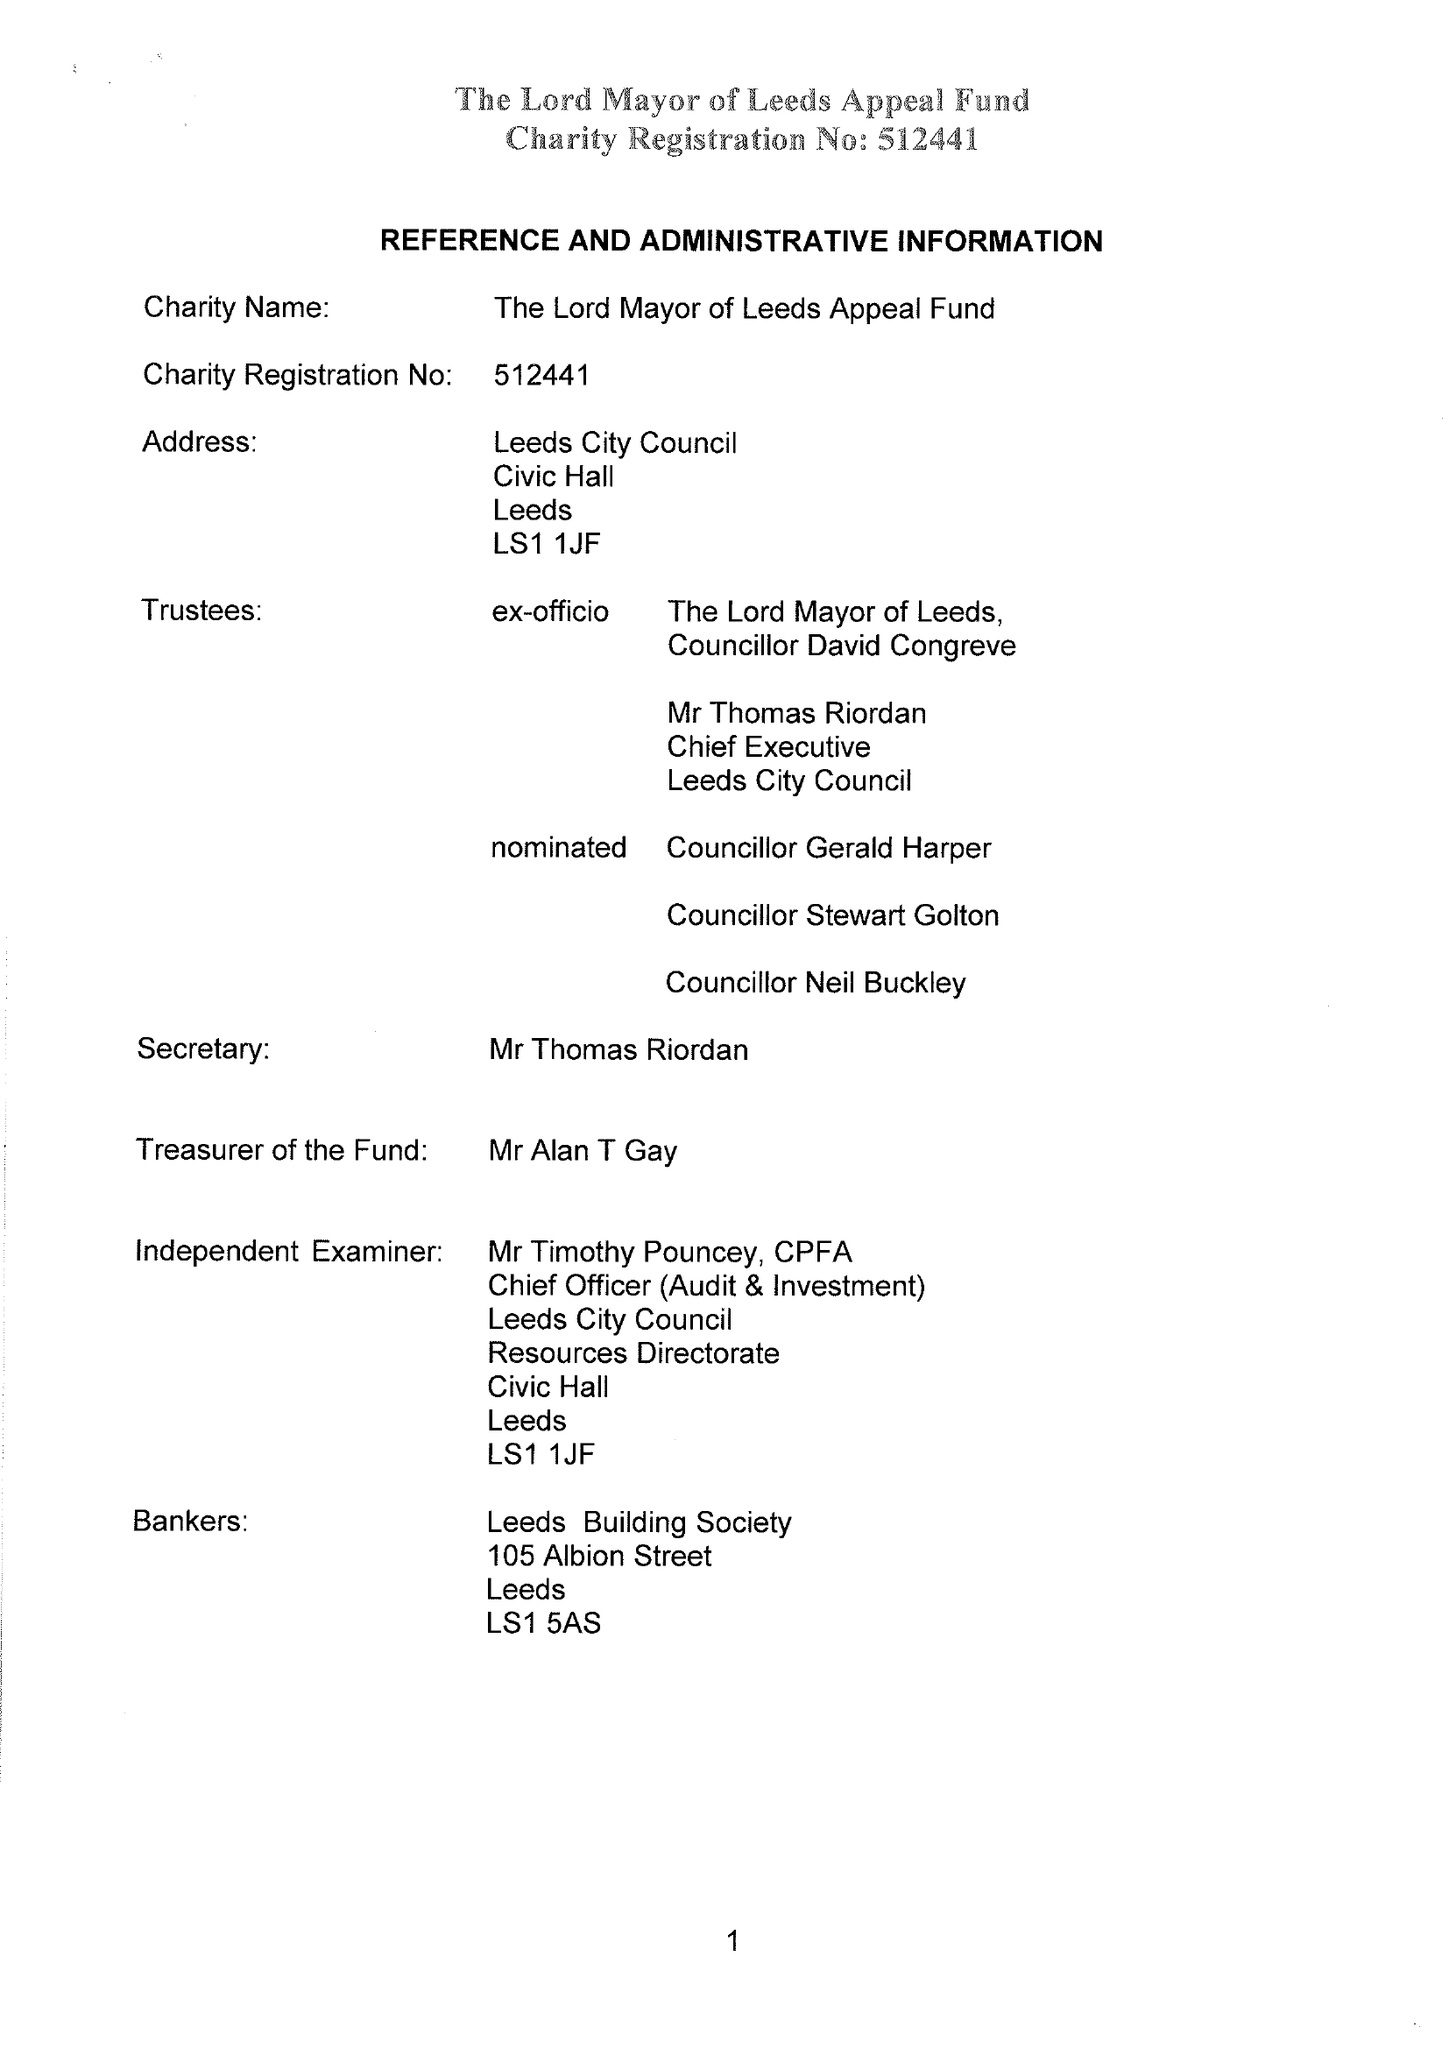What is the value for the address__postcode?
Answer the question using a single word or phrase. LS1 1JF 